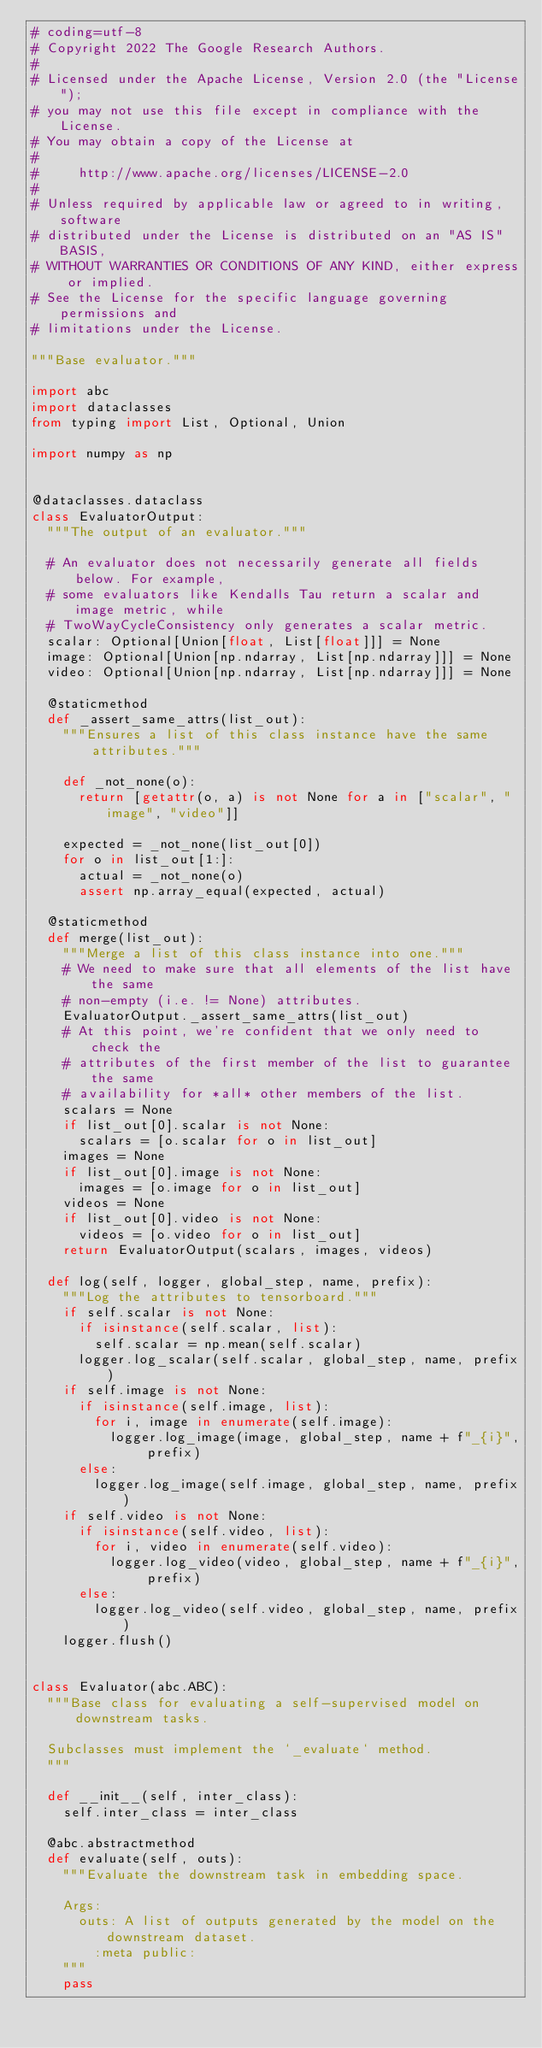<code> <loc_0><loc_0><loc_500><loc_500><_Python_># coding=utf-8
# Copyright 2022 The Google Research Authors.
#
# Licensed under the Apache License, Version 2.0 (the "License");
# you may not use this file except in compliance with the License.
# You may obtain a copy of the License at
#
#     http://www.apache.org/licenses/LICENSE-2.0
#
# Unless required by applicable law or agreed to in writing, software
# distributed under the License is distributed on an "AS IS" BASIS,
# WITHOUT WARRANTIES OR CONDITIONS OF ANY KIND, either express or implied.
# See the License for the specific language governing permissions and
# limitations under the License.

"""Base evaluator."""

import abc
import dataclasses
from typing import List, Optional, Union

import numpy as np


@dataclasses.dataclass
class EvaluatorOutput:
  """The output of an evaluator."""

  # An evaluator does not necessarily generate all fields below. For example,
  # some evaluators like Kendalls Tau return a scalar and image metric, while
  # TwoWayCycleConsistency only generates a scalar metric.
  scalar: Optional[Union[float, List[float]]] = None
  image: Optional[Union[np.ndarray, List[np.ndarray]]] = None
  video: Optional[Union[np.ndarray, List[np.ndarray]]] = None

  @staticmethod
  def _assert_same_attrs(list_out):
    """Ensures a list of this class instance have the same attributes."""

    def _not_none(o):
      return [getattr(o, a) is not None for a in ["scalar", "image", "video"]]

    expected = _not_none(list_out[0])
    for o in list_out[1:]:
      actual = _not_none(o)
      assert np.array_equal(expected, actual)

  @staticmethod
  def merge(list_out):
    """Merge a list of this class instance into one."""
    # We need to make sure that all elements of the list have the same
    # non-empty (i.e. != None) attributes.
    EvaluatorOutput._assert_same_attrs(list_out)
    # At this point, we're confident that we only need to check the
    # attributes of the first member of the list to guarantee the same
    # availability for *all* other members of the list.
    scalars = None
    if list_out[0].scalar is not None:
      scalars = [o.scalar for o in list_out]
    images = None
    if list_out[0].image is not None:
      images = [o.image for o in list_out]
    videos = None
    if list_out[0].video is not None:
      videos = [o.video for o in list_out]
    return EvaluatorOutput(scalars, images, videos)

  def log(self, logger, global_step, name, prefix):
    """Log the attributes to tensorboard."""
    if self.scalar is not None:
      if isinstance(self.scalar, list):
        self.scalar = np.mean(self.scalar)
      logger.log_scalar(self.scalar, global_step, name, prefix)
    if self.image is not None:
      if isinstance(self.image, list):
        for i, image in enumerate(self.image):
          logger.log_image(image, global_step, name + f"_{i}", prefix)
      else:
        logger.log_image(self.image, global_step, name, prefix)
    if self.video is not None:
      if isinstance(self.video, list):
        for i, video in enumerate(self.video):
          logger.log_video(video, global_step, name + f"_{i}", prefix)
      else:
        logger.log_video(self.video, global_step, name, prefix)
    logger.flush()


class Evaluator(abc.ABC):
  """Base class for evaluating a self-supervised model on downstream tasks.

  Subclasses must implement the `_evaluate` method.
  """

  def __init__(self, inter_class):
    self.inter_class = inter_class

  @abc.abstractmethod
  def evaluate(self, outs):
    """Evaluate the downstream task in embedding space.

    Args:
      outs: A list of outputs generated by the model on the downstream dataset.
        :meta public:
    """
    pass
</code> 